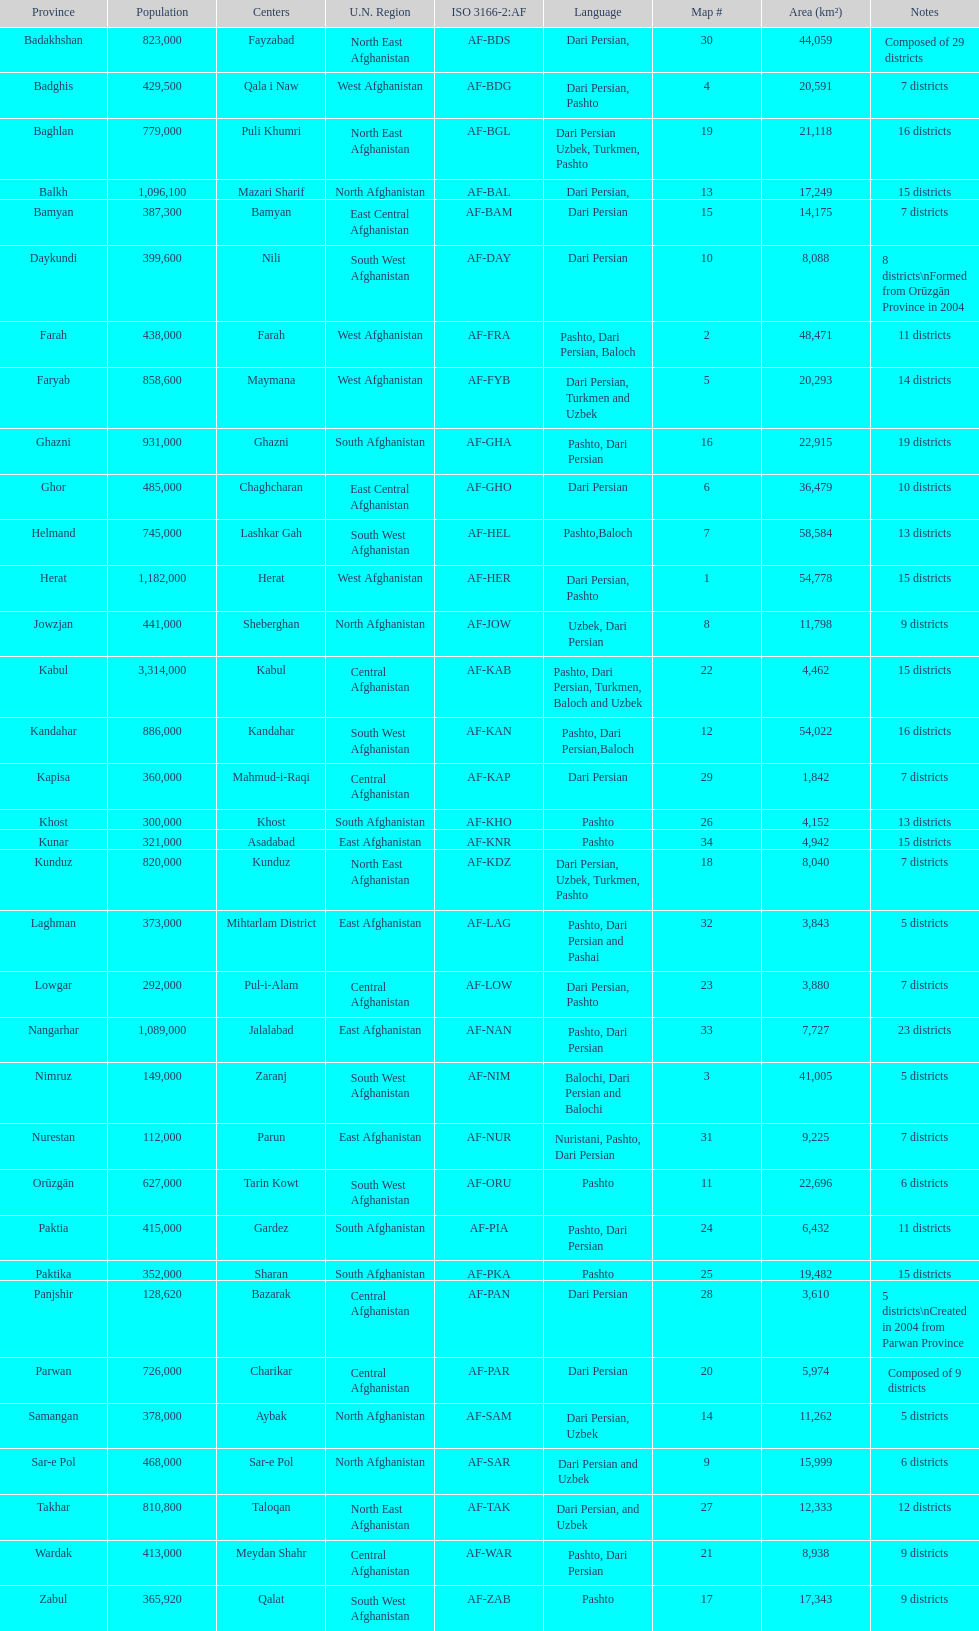How many provinces in afghanistan speak dari persian? 28. 